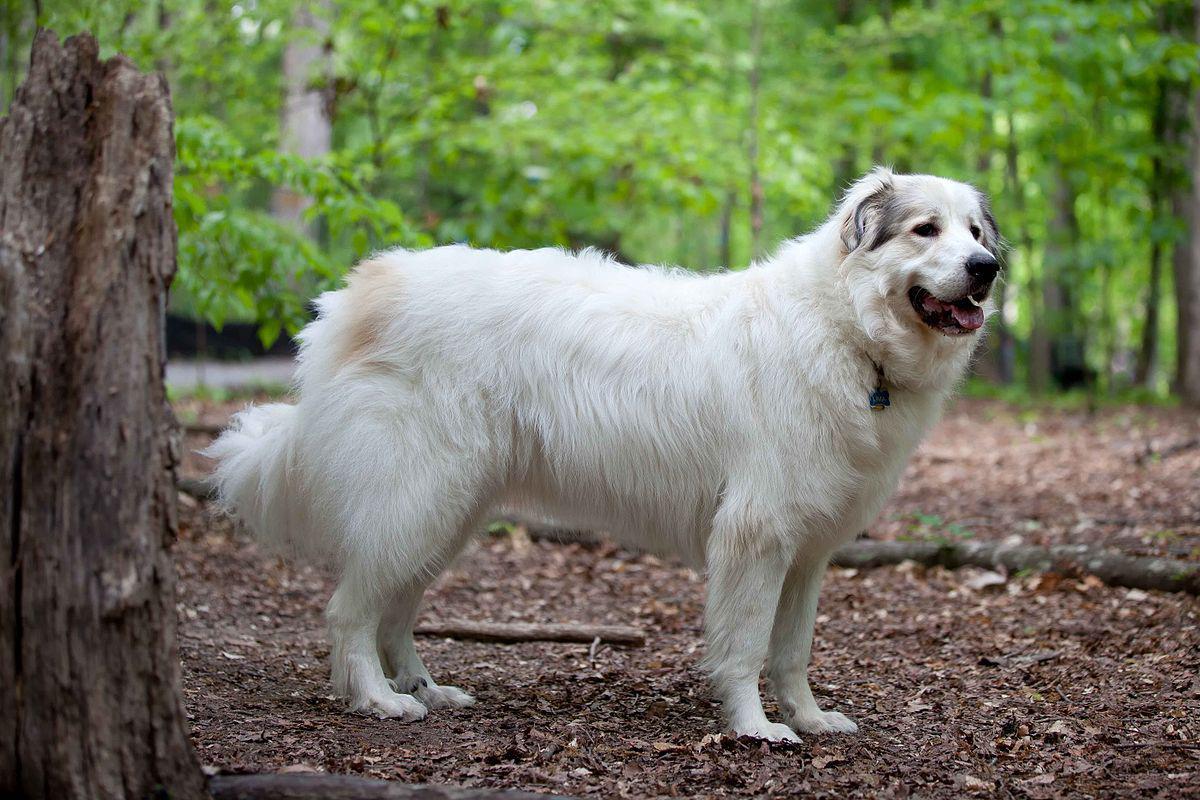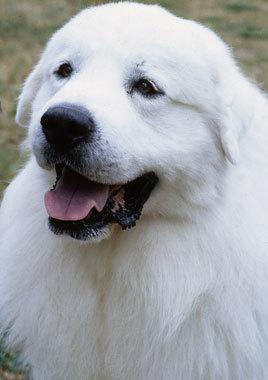The first image is the image on the left, the second image is the image on the right. Analyze the images presented: Is the assertion "One of the dogs is sitting with its legs extended on the ground." valid? Answer yes or no. No. 